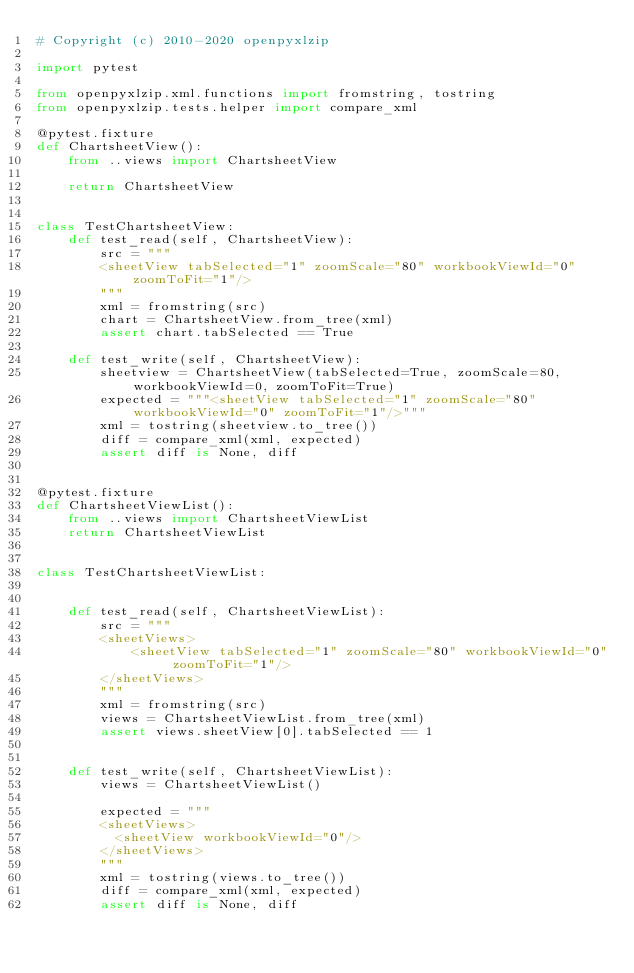<code> <loc_0><loc_0><loc_500><loc_500><_Python_># Copyright (c) 2010-2020 openpyxlzip

import pytest

from openpyxlzip.xml.functions import fromstring, tostring
from openpyxlzip.tests.helper import compare_xml

@pytest.fixture
def ChartsheetView():
    from ..views import ChartsheetView

    return ChartsheetView


class TestChartsheetView:
    def test_read(self, ChartsheetView):
        src = """
        <sheetView tabSelected="1" zoomScale="80" workbookViewId="0" zoomToFit="1"/>
        """
        xml = fromstring(src)
        chart = ChartsheetView.from_tree(xml)
        assert chart.tabSelected == True

    def test_write(self, ChartsheetView):
        sheetview = ChartsheetView(tabSelected=True, zoomScale=80, workbookViewId=0, zoomToFit=True)
        expected = """<sheetView tabSelected="1" zoomScale="80" workbookViewId="0" zoomToFit="1"/>"""
        xml = tostring(sheetview.to_tree())
        diff = compare_xml(xml, expected)
        assert diff is None, diff


@pytest.fixture
def ChartsheetViewList():
    from ..views import ChartsheetViewList
    return ChartsheetViewList


class TestChartsheetViewList:


    def test_read(self, ChartsheetViewList):
        src = """
        <sheetViews>
            <sheetView tabSelected="1" zoomScale="80" workbookViewId="0" zoomToFit="1"/>
        </sheetViews>
        """
        xml = fromstring(src)
        views = ChartsheetViewList.from_tree(xml)
        assert views.sheetView[0].tabSelected == 1


    def test_write(self, ChartsheetViewList):
        views = ChartsheetViewList()

        expected = """
        <sheetViews>
          <sheetView workbookViewId="0"/>
        </sheetViews>
        """
        xml = tostring(views.to_tree())
        diff = compare_xml(xml, expected)
        assert diff is None, diff
</code> 